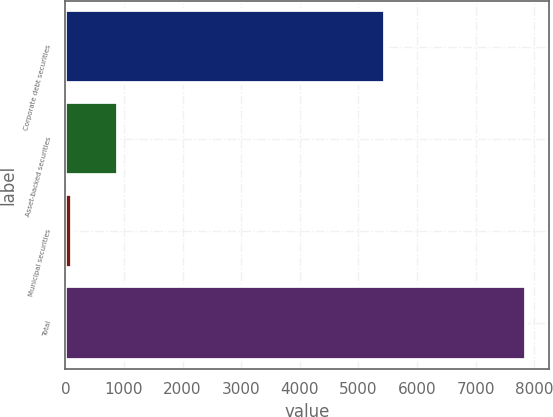<chart> <loc_0><loc_0><loc_500><loc_500><bar_chart><fcel>Corporate debt securities<fcel>Asset-backed securities<fcel>Municipal securities<fcel>Total<nl><fcel>5459<fcel>889.7<fcel>115<fcel>7862<nl></chart> 